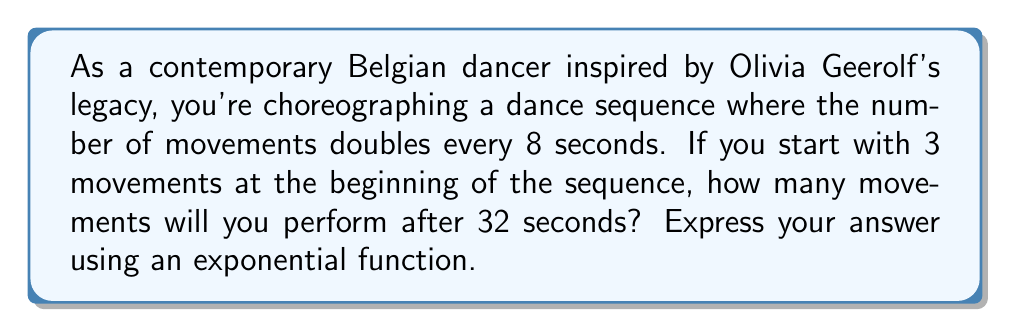Help me with this question. Let's approach this step-by-step:

1) We can model this situation using an exponential function of the form:
   $$ N(t) = N_0 \cdot 2^{\frac{t}{8}} $$
   Where:
   $N(t)$ is the number of movements at time $t$
   $N_0$ is the initial number of movements
   $t$ is the time in seconds

2) We're given that:
   $N_0 = 3$ (initial number of movements)
   $t = 32$ seconds

3) Let's substitute these values into our function:
   $$ N(32) = 3 \cdot 2^{\frac{32}{8}} $$

4) Simplify the exponent:
   $$ N(32) = 3 \cdot 2^4 $$

5) Calculate $2^4$:
   $$ N(32) = 3 \cdot 16 $$

6) Multiply:
   $$ N(32) = 48 $$

Therefore, after 32 seconds, you will perform 48 movements.
Answer: $N(t) = 3 \cdot 2^{\frac{t}{8}}$; $N(32) = 48$ movements 